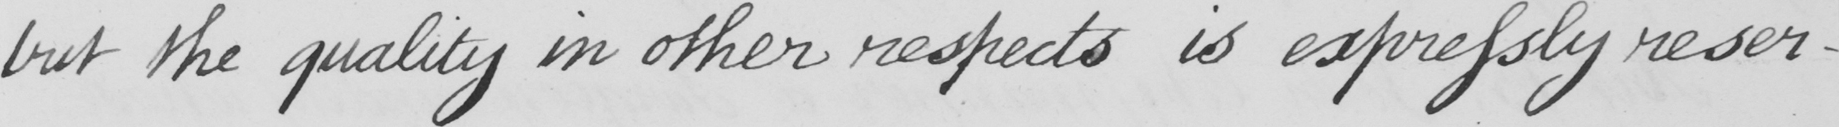Please transcribe the handwritten text in this image. but the quality in other respects is expressly reser- 